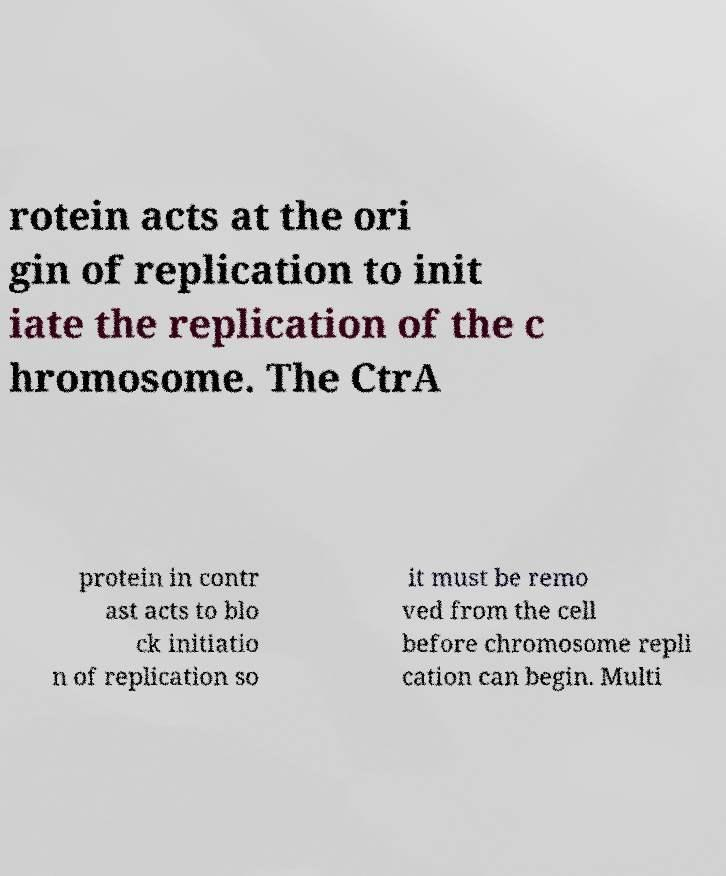Can you read and provide the text displayed in the image?This photo seems to have some interesting text. Can you extract and type it out for me? rotein acts at the ori gin of replication to init iate the replication of the c hromosome. The CtrA protein in contr ast acts to blo ck initiatio n of replication so it must be remo ved from the cell before chromosome repli cation can begin. Multi 